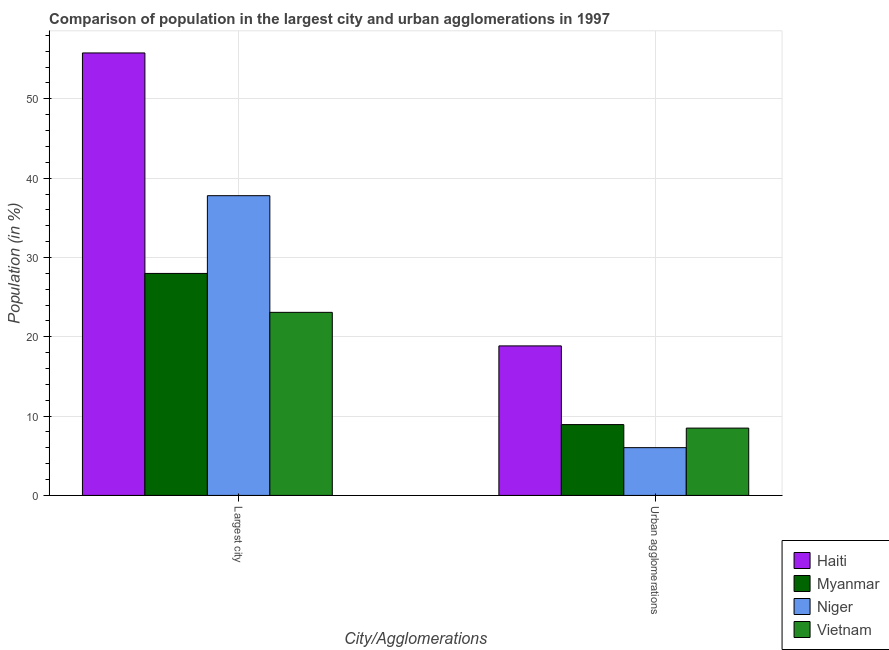Are the number of bars per tick equal to the number of legend labels?
Make the answer very short. Yes. How many bars are there on the 1st tick from the right?
Provide a succinct answer. 4. What is the label of the 1st group of bars from the left?
Ensure brevity in your answer.  Largest city. What is the population in urban agglomerations in Haiti?
Make the answer very short. 18.85. Across all countries, what is the maximum population in urban agglomerations?
Keep it short and to the point. 18.85. Across all countries, what is the minimum population in urban agglomerations?
Give a very brief answer. 6.02. In which country was the population in the largest city maximum?
Give a very brief answer. Haiti. In which country was the population in the largest city minimum?
Ensure brevity in your answer.  Vietnam. What is the total population in the largest city in the graph?
Ensure brevity in your answer.  144.64. What is the difference between the population in the largest city in Vietnam and that in Myanmar?
Provide a succinct answer. -4.91. What is the difference between the population in urban agglomerations in Haiti and the population in the largest city in Vietnam?
Your response must be concise. -4.23. What is the average population in urban agglomerations per country?
Your response must be concise. 10.57. What is the difference between the population in urban agglomerations and population in the largest city in Myanmar?
Keep it short and to the point. -19.06. What is the ratio of the population in the largest city in Niger to that in Haiti?
Provide a succinct answer. 0.68. What does the 2nd bar from the left in Urban agglomerations represents?
Offer a terse response. Myanmar. What does the 3rd bar from the right in Largest city represents?
Your answer should be very brief. Myanmar. Are all the bars in the graph horizontal?
Provide a succinct answer. No. How many countries are there in the graph?
Offer a terse response. 4. What is the difference between two consecutive major ticks on the Y-axis?
Ensure brevity in your answer.  10. Does the graph contain any zero values?
Provide a short and direct response. No. Where does the legend appear in the graph?
Provide a succinct answer. Bottom right. How many legend labels are there?
Offer a terse response. 4. How are the legend labels stacked?
Keep it short and to the point. Vertical. What is the title of the graph?
Your answer should be very brief. Comparison of population in the largest city and urban agglomerations in 1997. Does "Kazakhstan" appear as one of the legend labels in the graph?
Ensure brevity in your answer.  No. What is the label or title of the X-axis?
Offer a very short reply. City/Agglomerations. What is the label or title of the Y-axis?
Keep it short and to the point. Population (in %). What is the Population (in %) of Haiti in Largest city?
Provide a succinct answer. 55.78. What is the Population (in %) in Myanmar in Largest city?
Offer a very short reply. 27.99. What is the Population (in %) in Niger in Largest city?
Keep it short and to the point. 37.79. What is the Population (in %) in Vietnam in Largest city?
Make the answer very short. 23.08. What is the Population (in %) of Haiti in Urban agglomerations?
Make the answer very short. 18.85. What is the Population (in %) in Myanmar in Urban agglomerations?
Make the answer very short. 8.93. What is the Population (in %) of Niger in Urban agglomerations?
Your answer should be very brief. 6.02. What is the Population (in %) of Vietnam in Urban agglomerations?
Ensure brevity in your answer.  8.49. Across all City/Agglomerations, what is the maximum Population (in %) in Haiti?
Provide a short and direct response. 55.78. Across all City/Agglomerations, what is the maximum Population (in %) of Myanmar?
Your answer should be compact. 27.99. Across all City/Agglomerations, what is the maximum Population (in %) in Niger?
Keep it short and to the point. 37.79. Across all City/Agglomerations, what is the maximum Population (in %) of Vietnam?
Your answer should be compact. 23.08. Across all City/Agglomerations, what is the minimum Population (in %) in Haiti?
Offer a terse response. 18.85. Across all City/Agglomerations, what is the minimum Population (in %) of Myanmar?
Give a very brief answer. 8.93. Across all City/Agglomerations, what is the minimum Population (in %) of Niger?
Your answer should be very brief. 6.02. Across all City/Agglomerations, what is the minimum Population (in %) of Vietnam?
Provide a short and direct response. 8.49. What is the total Population (in %) in Haiti in the graph?
Your response must be concise. 74.63. What is the total Population (in %) of Myanmar in the graph?
Keep it short and to the point. 36.92. What is the total Population (in %) of Niger in the graph?
Make the answer very short. 43.81. What is the total Population (in %) of Vietnam in the graph?
Give a very brief answer. 31.57. What is the difference between the Population (in %) in Haiti in Largest city and that in Urban agglomerations?
Provide a succinct answer. 36.93. What is the difference between the Population (in %) of Myanmar in Largest city and that in Urban agglomerations?
Your answer should be compact. 19.06. What is the difference between the Population (in %) of Niger in Largest city and that in Urban agglomerations?
Make the answer very short. 31.77. What is the difference between the Population (in %) of Vietnam in Largest city and that in Urban agglomerations?
Keep it short and to the point. 14.59. What is the difference between the Population (in %) in Haiti in Largest city and the Population (in %) in Myanmar in Urban agglomerations?
Provide a succinct answer. 46.85. What is the difference between the Population (in %) in Haiti in Largest city and the Population (in %) in Niger in Urban agglomerations?
Offer a very short reply. 49.76. What is the difference between the Population (in %) in Haiti in Largest city and the Population (in %) in Vietnam in Urban agglomerations?
Your answer should be very brief. 47.3. What is the difference between the Population (in %) of Myanmar in Largest city and the Population (in %) of Niger in Urban agglomerations?
Offer a very short reply. 21.96. What is the difference between the Population (in %) in Myanmar in Largest city and the Population (in %) in Vietnam in Urban agglomerations?
Ensure brevity in your answer.  19.5. What is the difference between the Population (in %) of Niger in Largest city and the Population (in %) of Vietnam in Urban agglomerations?
Keep it short and to the point. 29.3. What is the average Population (in %) of Haiti per City/Agglomerations?
Your answer should be very brief. 37.32. What is the average Population (in %) in Myanmar per City/Agglomerations?
Your answer should be compact. 18.46. What is the average Population (in %) of Niger per City/Agglomerations?
Keep it short and to the point. 21.91. What is the average Population (in %) in Vietnam per City/Agglomerations?
Provide a succinct answer. 15.78. What is the difference between the Population (in %) of Haiti and Population (in %) of Myanmar in Largest city?
Offer a very short reply. 27.8. What is the difference between the Population (in %) of Haiti and Population (in %) of Niger in Largest city?
Offer a terse response. 17.99. What is the difference between the Population (in %) of Haiti and Population (in %) of Vietnam in Largest city?
Keep it short and to the point. 32.7. What is the difference between the Population (in %) in Myanmar and Population (in %) in Niger in Largest city?
Your answer should be compact. -9.8. What is the difference between the Population (in %) in Myanmar and Population (in %) in Vietnam in Largest city?
Provide a short and direct response. 4.91. What is the difference between the Population (in %) in Niger and Population (in %) in Vietnam in Largest city?
Provide a succinct answer. 14.71. What is the difference between the Population (in %) of Haiti and Population (in %) of Myanmar in Urban agglomerations?
Make the answer very short. 9.92. What is the difference between the Population (in %) in Haiti and Population (in %) in Niger in Urban agglomerations?
Provide a short and direct response. 12.83. What is the difference between the Population (in %) of Haiti and Population (in %) of Vietnam in Urban agglomerations?
Your answer should be compact. 10.36. What is the difference between the Population (in %) of Myanmar and Population (in %) of Niger in Urban agglomerations?
Provide a succinct answer. 2.91. What is the difference between the Population (in %) in Myanmar and Population (in %) in Vietnam in Urban agglomerations?
Keep it short and to the point. 0.44. What is the difference between the Population (in %) of Niger and Population (in %) of Vietnam in Urban agglomerations?
Your response must be concise. -2.46. What is the ratio of the Population (in %) in Haiti in Largest city to that in Urban agglomerations?
Give a very brief answer. 2.96. What is the ratio of the Population (in %) in Myanmar in Largest city to that in Urban agglomerations?
Give a very brief answer. 3.13. What is the ratio of the Population (in %) of Niger in Largest city to that in Urban agglomerations?
Keep it short and to the point. 6.27. What is the ratio of the Population (in %) of Vietnam in Largest city to that in Urban agglomerations?
Offer a very short reply. 2.72. What is the difference between the highest and the second highest Population (in %) of Haiti?
Make the answer very short. 36.93. What is the difference between the highest and the second highest Population (in %) in Myanmar?
Provide a succinct answer. 19.06. What is the difference between the highest and the second highest Population (in %) in Niger?
Offer a very short reply. 31.77. What is the difference between the highest and the second highest Population (in %) in Vietnam?
Your response must be concise. 14.59. What is the difference between the highest and the lowest Population (in %) in Haiti?
Your answer should be very brief. 36.93. What is the difference between the highest and the lowest Population (in %) of Myanmar?
Keep it short and to the point. 19.06. What is the difference between the highest and the lowest Population (in %) in Niger?
Offer a very short reply. 31.77. What is the difference between the highest and the lowest Population (in %) in Vietnam?
Keep it short and to the point. 14.59. 